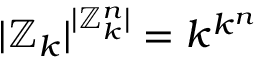<formula> <loc_0><loc_0><loc_500><loc_500>| \mathbb { Z } _ { k } | ^ { | \mathbb { Z } _ { k } ^ { n } | } = k ^ { k ^ { n } }</formula> 